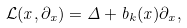<formula> <loc_0><loc_0><loc_500><loc_500>{ \mathcal { L } } ( x , \partial _ { x } ) = \Delta + b _ { k } ( x ) \partial _ { x } ,</formula> 